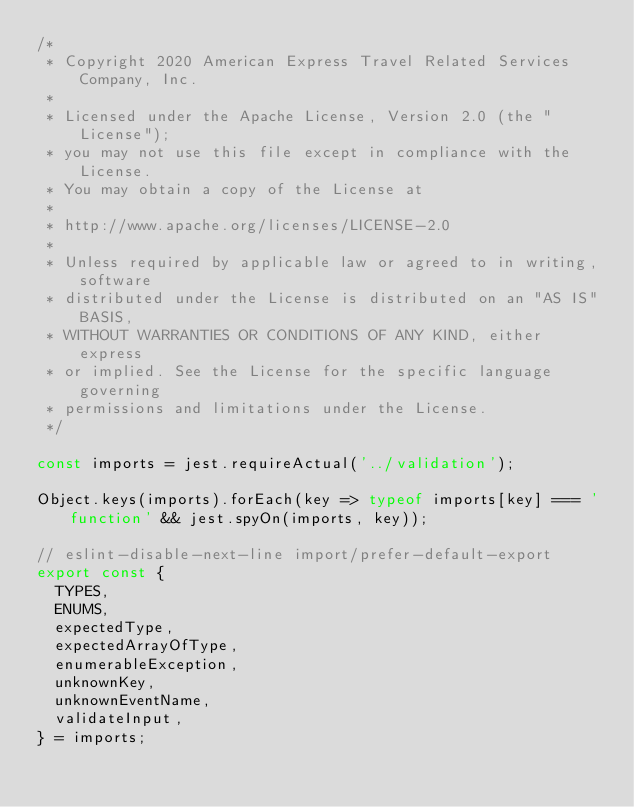<code> <loc_0><loc_0><loc_500><loc_500><_JavaScript_>/*
 * Copyright 2020 American Express Travel Related Services Company, Inc.
 *
 * Licensed under the Apache License, Version 2.0 (the "License");
 * you may not use this file except in compliance with the License.
 * You may obtain a copy of the License at
 *
 * http://www.apache.org/licenses/LICENSE-2.0
 *
 * Unless required by applicable law or agreed to in writing, software
 * distributed under the License is distributed on an "AS IS" BASIS,
 * WITHOUT WARRANTIES OR CONDITIONS OF ANY KIND, either express
 * or implied. See the License for the specific language governing
 * permissions and limitations under the License.
 */

const imports = jest.requireActual('../validation');

Object.keys(imports).forEach(key => typeof imports[key] === 'function' && jest.spyOn(imports, key));

// eslint-disable-next-line import/prefer-default-export
export const {
  TYPES,
  ENUMS,
  expectedType,
  expectedArrayOfType,
  enumerableException,
  unknownKey,
  unknownEventName,
  validateInput,
} = imports;
</code> 